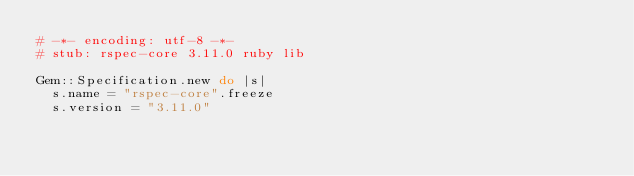Convert code to text. <code><loc_0><loc_0><loc_500><loc_500><_Ruby_># -*- encoding: utf-8 -*-
# stub: rspec-core 3.11.0 ruby lib

Gem::Specification.new do |s|
  s.name = "rspec-core".freeze
  s.version = "3.11.0"
</code> 